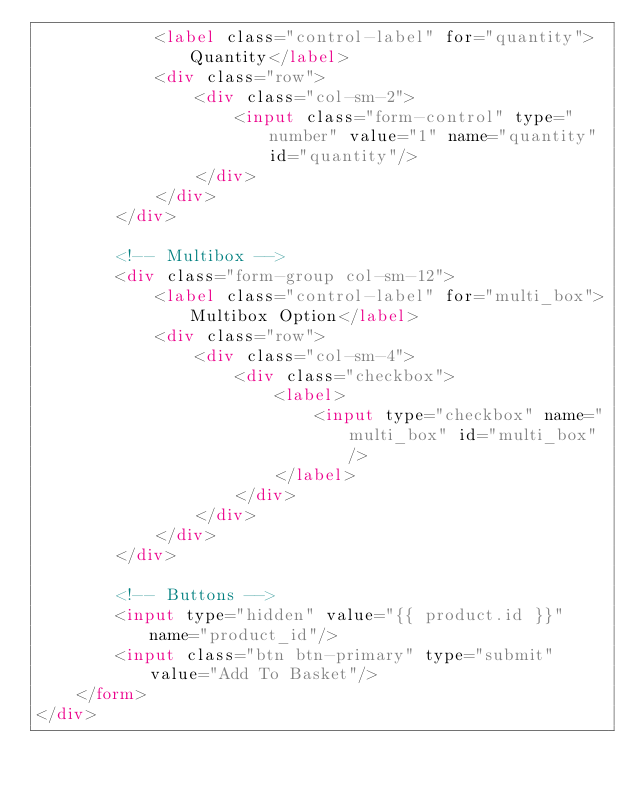Convert code to text. <code><loc_0><loc_0><loc_500><loc_500><_HTML_>            <label class="control-label" for="quantity">Quantity</label>
            <div class="row">
                <div class="col-sm-2">
                    <input class="form-control" type="number" value="1" name="quantity" id="quantity"/>
                </div>
            </div>
        </div>

        <!-- Multibox -->
        <div class="form-group col-sm-12">
            <label class="control-label" for="multi_box">Multibox Option</label>
            <div class="row">
                <div class="col-sm-4">
                    <div class="checkbox">
                        <label>
                            <input type="checkbox" name="multi_box" id="multi_box"/>
                        </label>
                    </div>
                </div>
            </div>
        </div>

        <!-- Buttons -->
        <input type="hidden" value="{{ product.id }}" name="product_id"/>
        <input class="btn btn-primary" type="submit" value="Add To Basket"/>
    </form>
</div>
</code> 